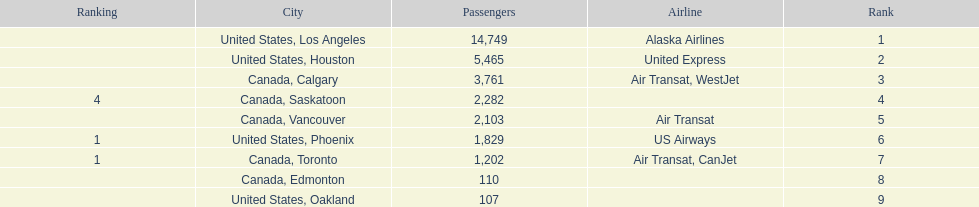Was los angeles or houston the busiest international route at manzanillo international airport in 2013? Los Angeles. Parse the full table. {'header': ['Ranking', 'City', 'Passengers', 'Airline', 'Rank'], 'rows': [['', 'United States, Los Angeles', '14,749', 'Alaska Airlines', '1'], ['', 'United States, Houston', '5,465', 'United Express', '2'], ['', 'Canada, Calgary', '3,761', 'Air Transat, WestJet', '3'], ['4', 'Canada, Saskatoon', '2,282', '', '4'], ['', 'Canada, Vancouver', '2,103', 'Air Transat', '5'], ['1', 'United States, Phoenix', '1,829', 'US Airways', '6'], ['1', 'Canada, Toronto', '1,202', 'Air Transat, CanJet', '7'], ['', 'Canada, Edmonton', '110', '', '8'], ['', 'United States, Oakland', '107', '', '9']]} 